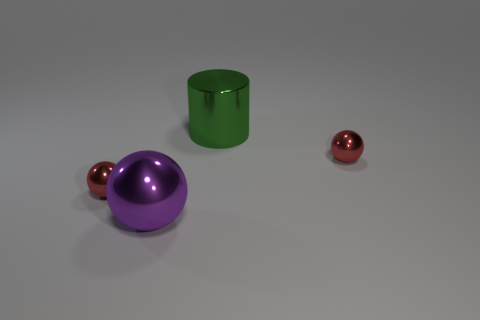The big purple object to the left of the large green object has what shape? sphere 